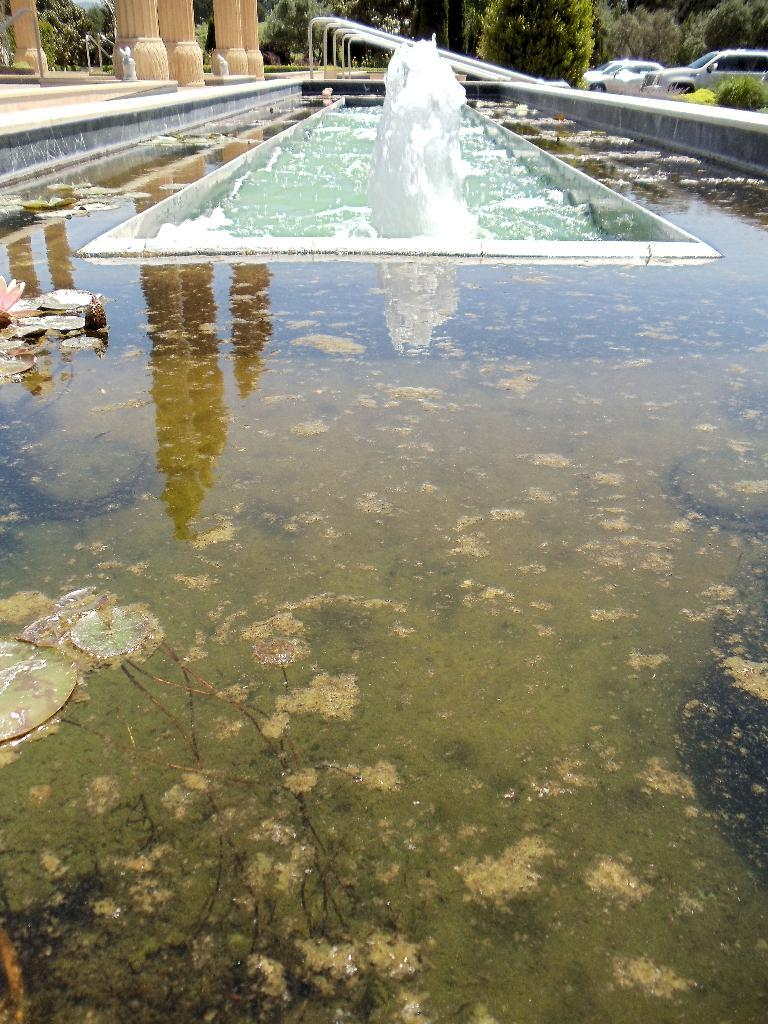What is present in the image that is related to water? There is water in the image. What can be found in the water in the image? There is a fortune in the water. What structures are present in the image? There are poles and cream pillars in the image. What can be seen in the background of the image? There are trees and cars visible in the background. What month is it in the image? The month cannot be determined from the image, as it does not contain any information about the time of year. Can you see any cords in the image? There are no cords visible in the image. 